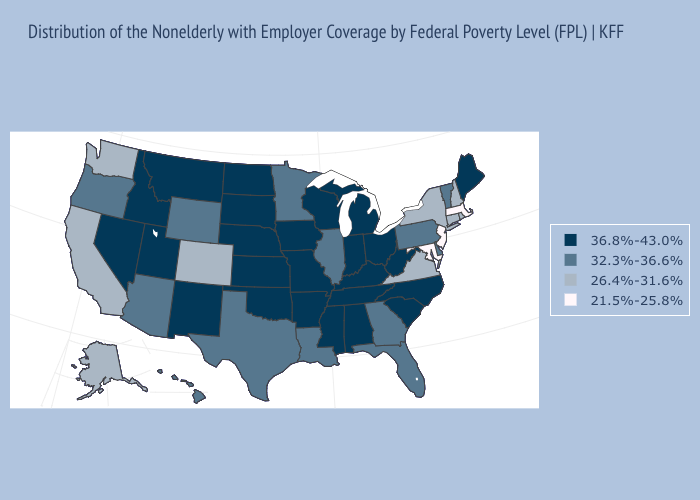What is the value of Rhode Island?
Be succinct. 26.4%-31.6%. Does Delaware have a lower value than New Hampshire?
Short answer required. No. Name the states that have a value in the range 21.5%-25.8%?
Quick response, please. Maryland, Massachusetts, New Jersey. Among the states that border Oklahoma , does Colorado have the lowest value?
Give a very brief answer. Yes. Name the states that have a value in the range 36.8%-43.0%?
Keep it brief. Alabama, Arkansas, Idaho, Indiana, Iowa, Kansas, Kentucky, Maine, Michigan, Mississippi, Missouri, Montana, Nebraska, Nevada, New Mexico, North Carolina, North Dakota, Ohio, Oklahoma, South Carolina, South Dakota, Tennessee, Utah, West Virginia, Wisconsin. Which states have the lowest value in the USA?
Be succinct. Maryland, Massachusetts, New Jersey. Which states have the highest value in the USA?
Answer briefly. Alabama, Arkansas, Idaho, Indiana, Iowa, Kansas, Kentucky, Maine, Michigan, Mississippi, Missouri, Montana, Nebraska, Nevada, New Mexico, North Carolina, North Dakota, Ohio, Oklahoma, South Carolina, South Dakota, Tennessee, Utah, West Virginia, Wisconsin. How many symbols are there in the legend?
Keep it brief. 4. What is the value of Ohio?
Quick response, please. 36.8%-43.0%. Name the states that have a value in the range 36.8%-43.0%?
Keep it brief. Alabama, Arkansas, Idaho, Indiana, Iowa, Kansas, Kentucky, Maine, Michigan, Mississippi, Missouri, Montana, Nebraska, Nevada, New Mexico, North Carolina, North Dakota, Ohio, Oklahoma, South Carolina, South Dakota, Tennessee, Utah, West Virginia, Wisconsin. Which states hav the highest value in the MidWest?
Short answer required. Indiana, Iowa, Kansas, Michigan, Missouri, Nebraska, North Dakota, Ohio, South Dakota, Wisconsin. What is the highest value in the West ?
Write a very short answer. 36.8%-43.0%. What is the highest value in the Northeast ?
Quick response, please. 36.8%-43.0%. What is the value of Mississippi?
Keep it brief. 36.8%-43.0%. Is the legend a continuous bar?
Concise answer only. No. 